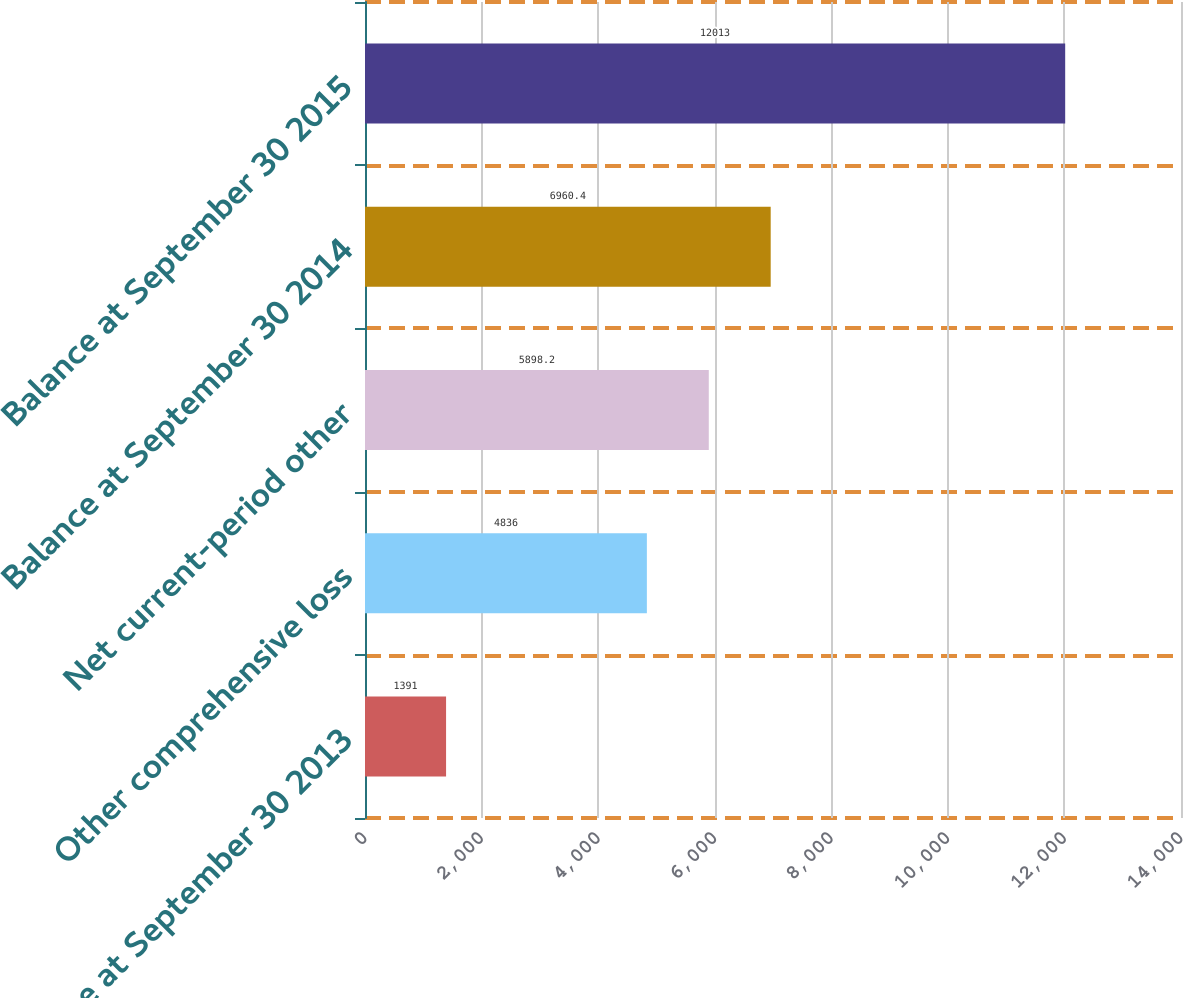<chart> <loc_0><loc_0><loc_500><loc_500><bar_chart><fcel>Balance at September 30 2013<fcel>Other comprehensive loss<fcel>Net current-period other<fcel>Balance at September 30 2014<fcel>Balance at September 30 2015<nl><fcel>1391<fcel>4836<fcel>5898.2<fcel>6960.4<fcel>12013<nl></chart> 